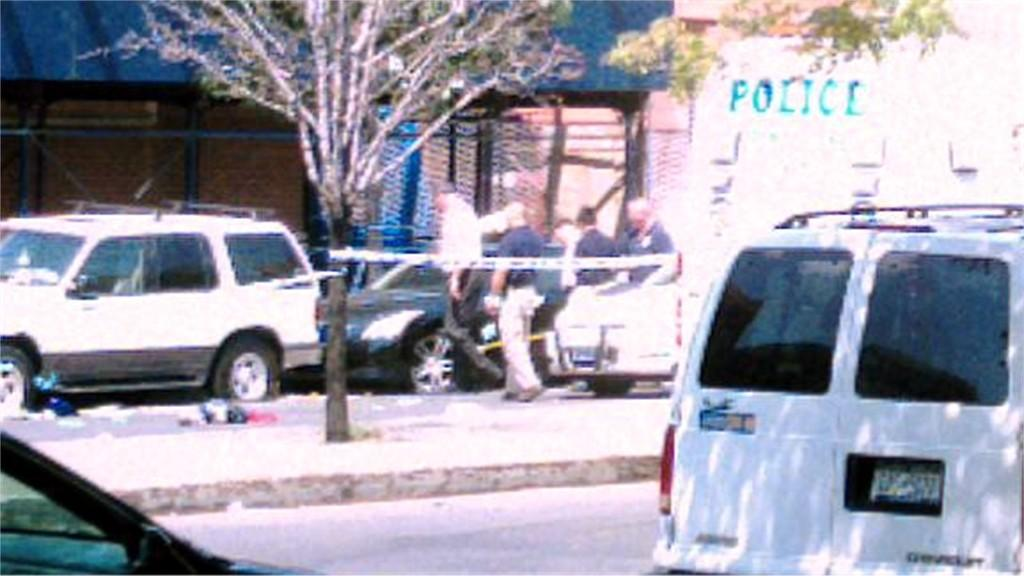<image>
Summarize the visual content of the image. A white police van is parked on a street and some men are walking around. 